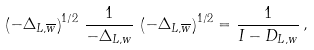<formula> <loc_0><loc_0><loc_500><loc_500>\left ( - \Delta _ { L , \overline { w } } \right ) ^ { 1 / 2 } \, \frac { 1 } { - \Delta _ { L , w } } \, \left ( - \Delta _ { L , \overline { w } } \right ) ^ { 1 / 2 } = \frac { 1 } { I - D _ { L , w } } \, ,</formula> 